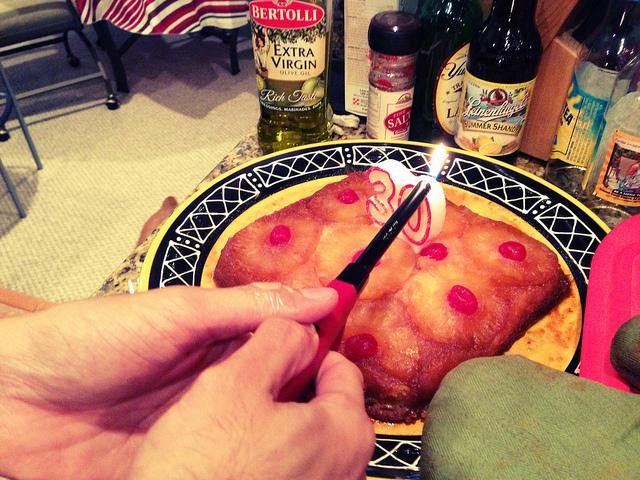What kind of cake Is on the plate?
Quick response, please. Pineapple upside down. Is there a bottle of extra virgin olive oil?
Short answer required. Yes. What color is the plate?
Be succinct. Yellow, black and white. 